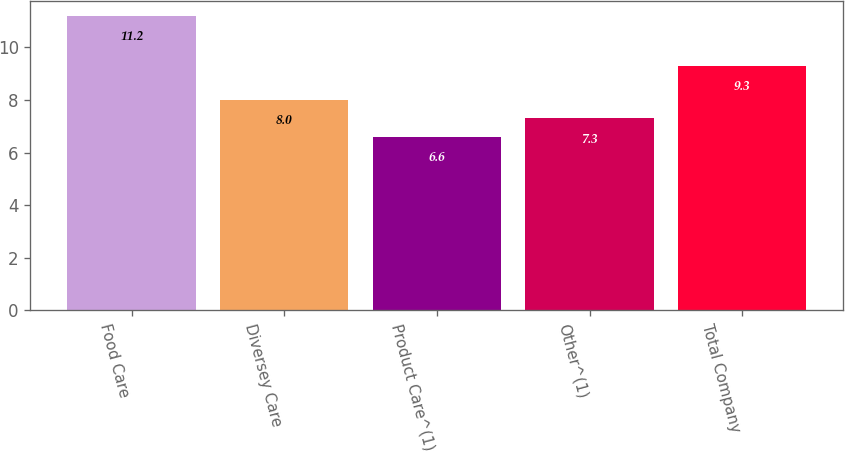Convert chart to OTSL. <chart><loc_0><loc_0><loc_500><loc_500><bar_chart><fcel>Food Care<fcel>Diversey Care<fcel>Product Care^(1)<fcel>Other^(1)<fcel>Total Company<nl><fcel>11.2<fcel>8<fcel>6.6<fcel>7.3<fcel>9.3<nl></chart> 